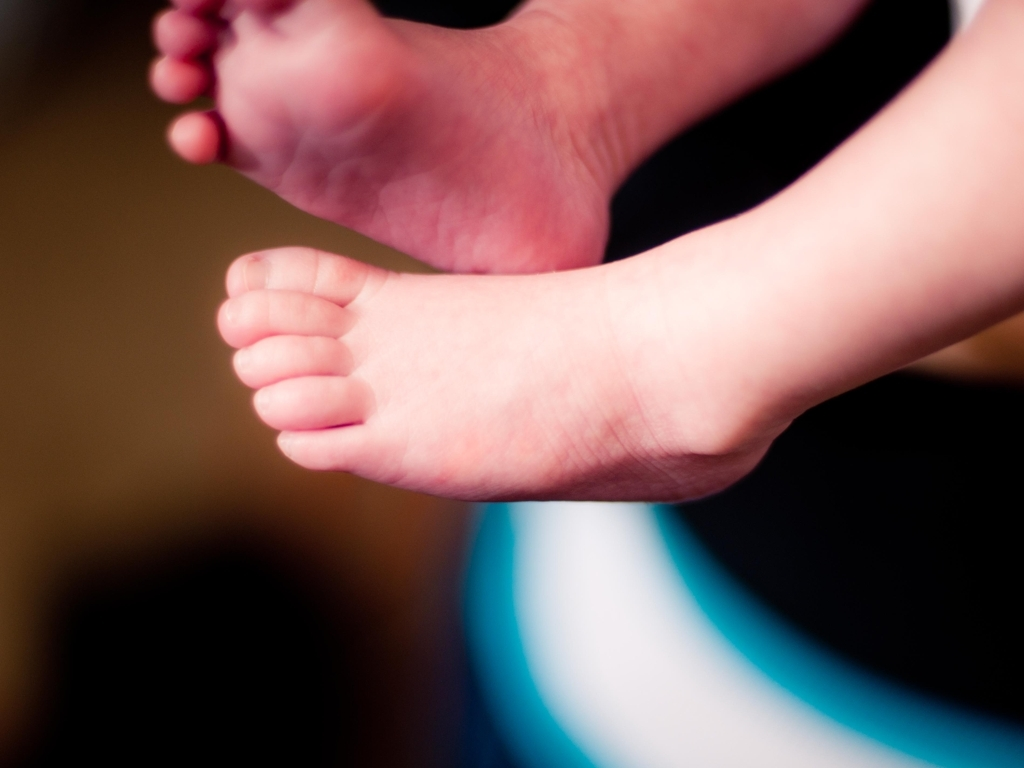Can you describe the main subject of this image? The photo showcases the feet of a small child or baby. They are positioned in a way that suggests comfort and relaxation, possibly lying down. The skin is soft and the toes are tiny and delicate, which is typical of young children at an early development stage. 